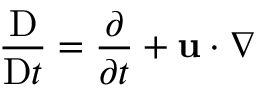Convert formula to latex. <formula><loc_0><loc_0><loc_500><loc_500>\frac { D } { D t } = \frac { \partial } { \partial t } + u \cdot \nabla</formula> 